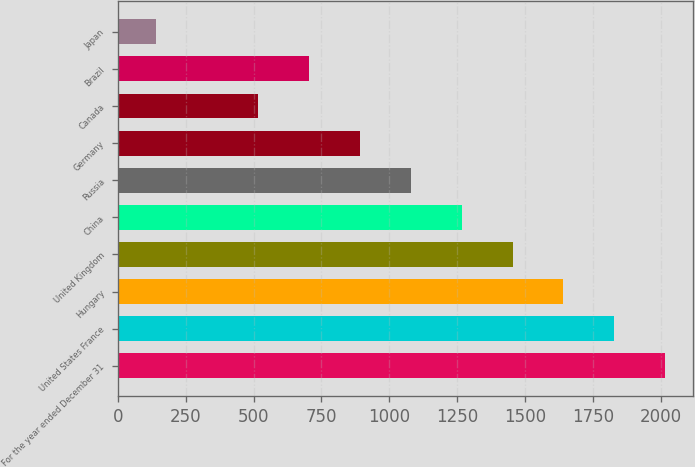Convert chart. <chart><loc_0><loc_0><loc_500><loc_500><bar_chart><fcel>For the year ended December 31<fcel>United States France<fcel>Hungary<fcel>United Kingdom<fcel>China<fcel>Russia<fcel>Germany<fcel>Canada<fcel>Brazil<fcel>Japan<nl><fcel>2017<fcel>1829.4<fcel>1641.8<fcel>1454.2<fcel>1266.6<fcel>1079<fcel>891.4<fcel>516.2<fcel>703.8<fcel>141<nl></chart> 